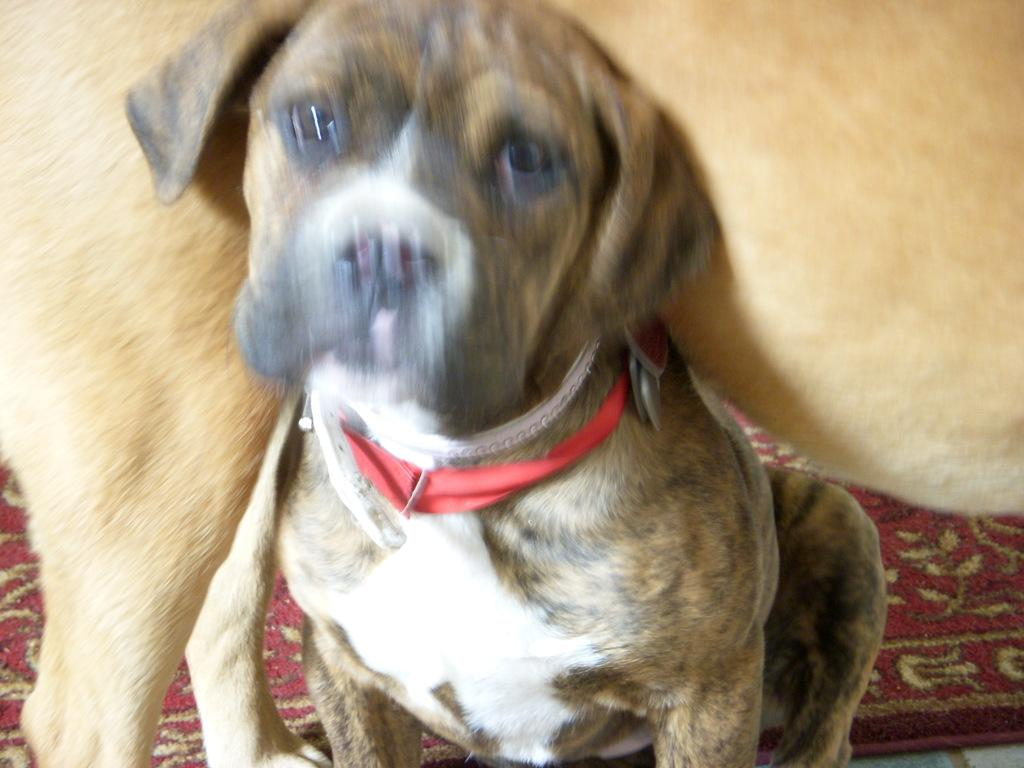What animal is sitting on the floor mat in the image? There is a dog sitting on the floor mat in the image. Can you describe the position of the second dog in the image? There is another dog standing on the floor mat and/or the first dog in the image. What type of blade is being used by the dog in the image? There is no blade present in the image; it is a picture of two dogs on a floor mat. 